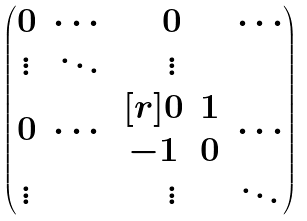Convert formula to latex. <formula><loc_0><loc_0><loc_500><loc_500>\begin{pmatrix} 0 & \cdots & 0 & \cdots \\ \vdots & \ddots & \vdots \\ 0 & \cdots & \begin{matrix} [ r ] 0 & 1 \\ - 1 & 0 \end{matrix} & \cdots \\ \vdots & & \vdots & \ddots \end{pmatrix}</formula> 